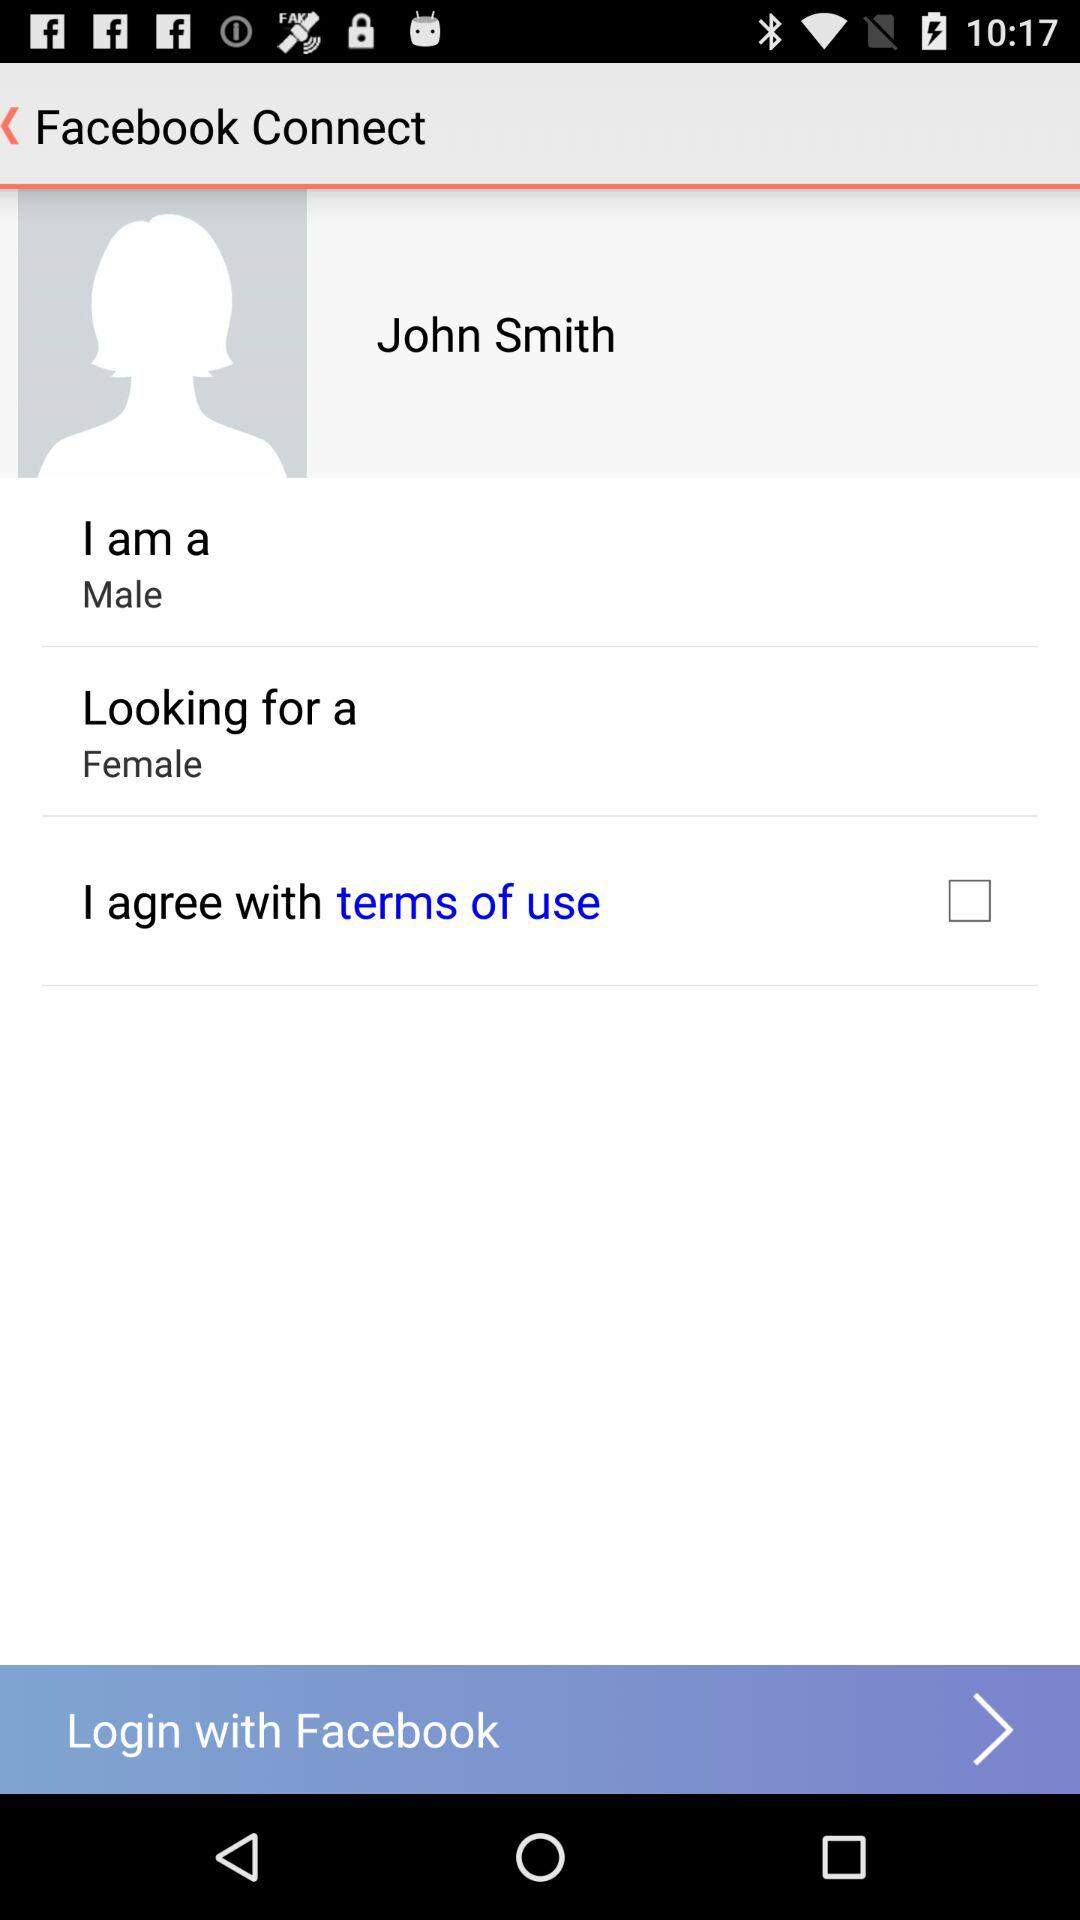Which gender is the user searching for? The user is searching for a female. 